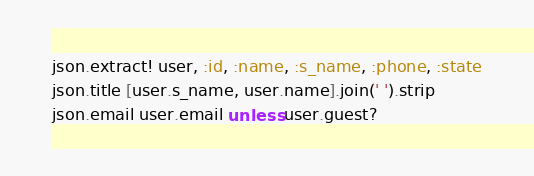Convert code to text. <code><loc_0><loc_0><loc_500><loc_500><_Ruby_>json.extract! user, :id, :name, :s_name, :phone, :state
json.title [user.s_name, user.name].join(' ').strip
json.email user.email unless user.guest?
</code> 